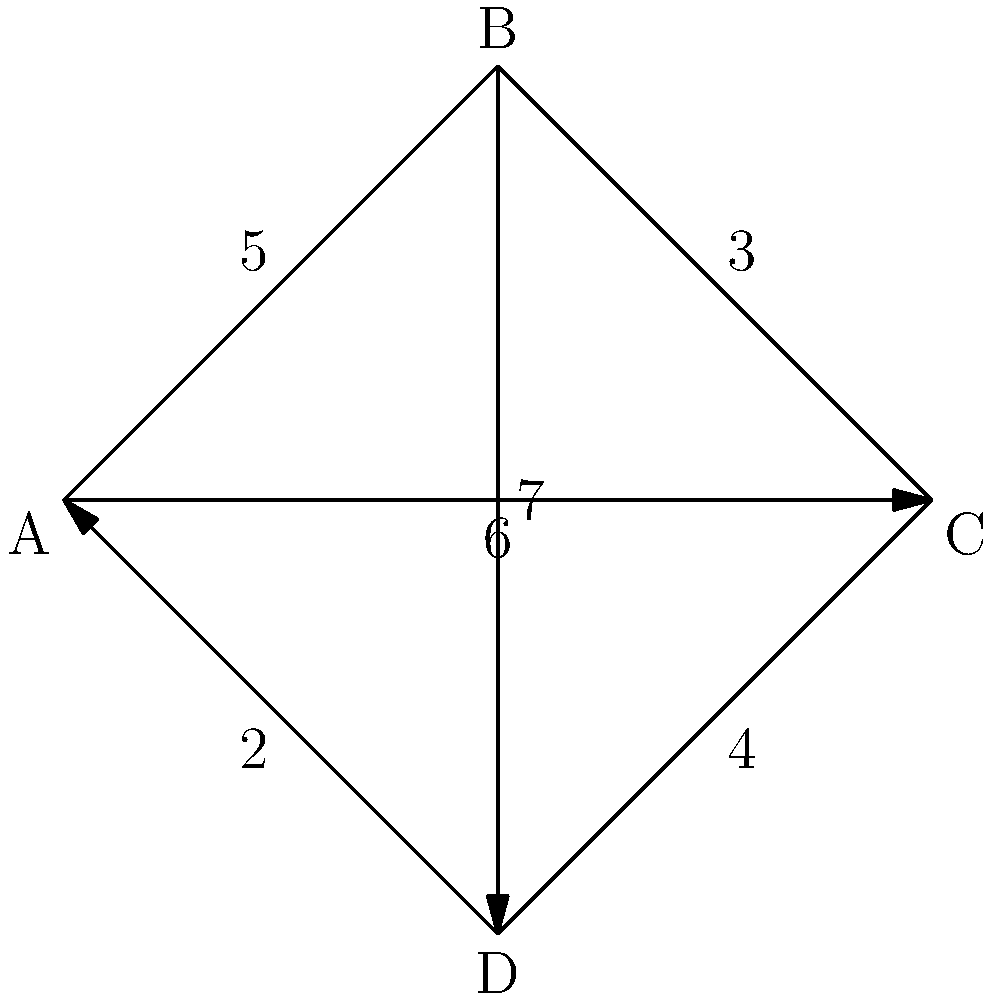Given the network diagram above representing a resource allocation problem, where nodes represent processing units and edge weights represent data transfer costs, find the minimum cost path from node A to node C. Assume that the optimization goal is to minimize the total data transfer cost while ensuring all data passes through exactly one intermediate node (B or D). How would you formulate this as a linear programming problem? To formulate this as a linear programming problem, we follow these steps:

1. Define decision variables:
   Let $x_1$ be the flow through path A-B-C
   Let $x_2$ be the flow through path A-D-C

2. Objective function:
   Minimize total cost: $Z = 8x_1 + 8x_2$
   (Cost for A-B-C = 5 + 3 = 8, Cost for A-D-C = 2 + 6 = 8)

3. Constraints:
   a) Flow conservation: All data must be transferred
      $x_1 + x_2 = 1$

   b) Non-negativity: Flows cannot be negative
      $x_1 \geq 0$
      $x_2 \geq 0$

4. Complete linear programming formulation:
   
   Minimize $Z = 8x_1 + 8x_2$
   
   Subject to:
   $x_1 + x_2 = 1$
   $x_1 \geq 0$
   $x_2 \geq 0$

5. Solving the LP:
   Since both paths have the same cost (8), any feasible solution satisfying the constraints is optimal. The optimal solution set is:
   $\{(x_1, x_2) | x_1 + x_2 = 1, x_1 \geq 0, x_2 \geq 0\}$

6. Interpretation:
   The minimum cost is 8 units, and it can be achieved by sending all data through either path A-B-C or A-D-C, or any combination of the two paths.
Answer: Minimize $Z = 8x_1 + 8x_2$ subject to $x_1 + x_2 = 1$, $x_1 \geq 0$, $x_2 \geq 0$ 